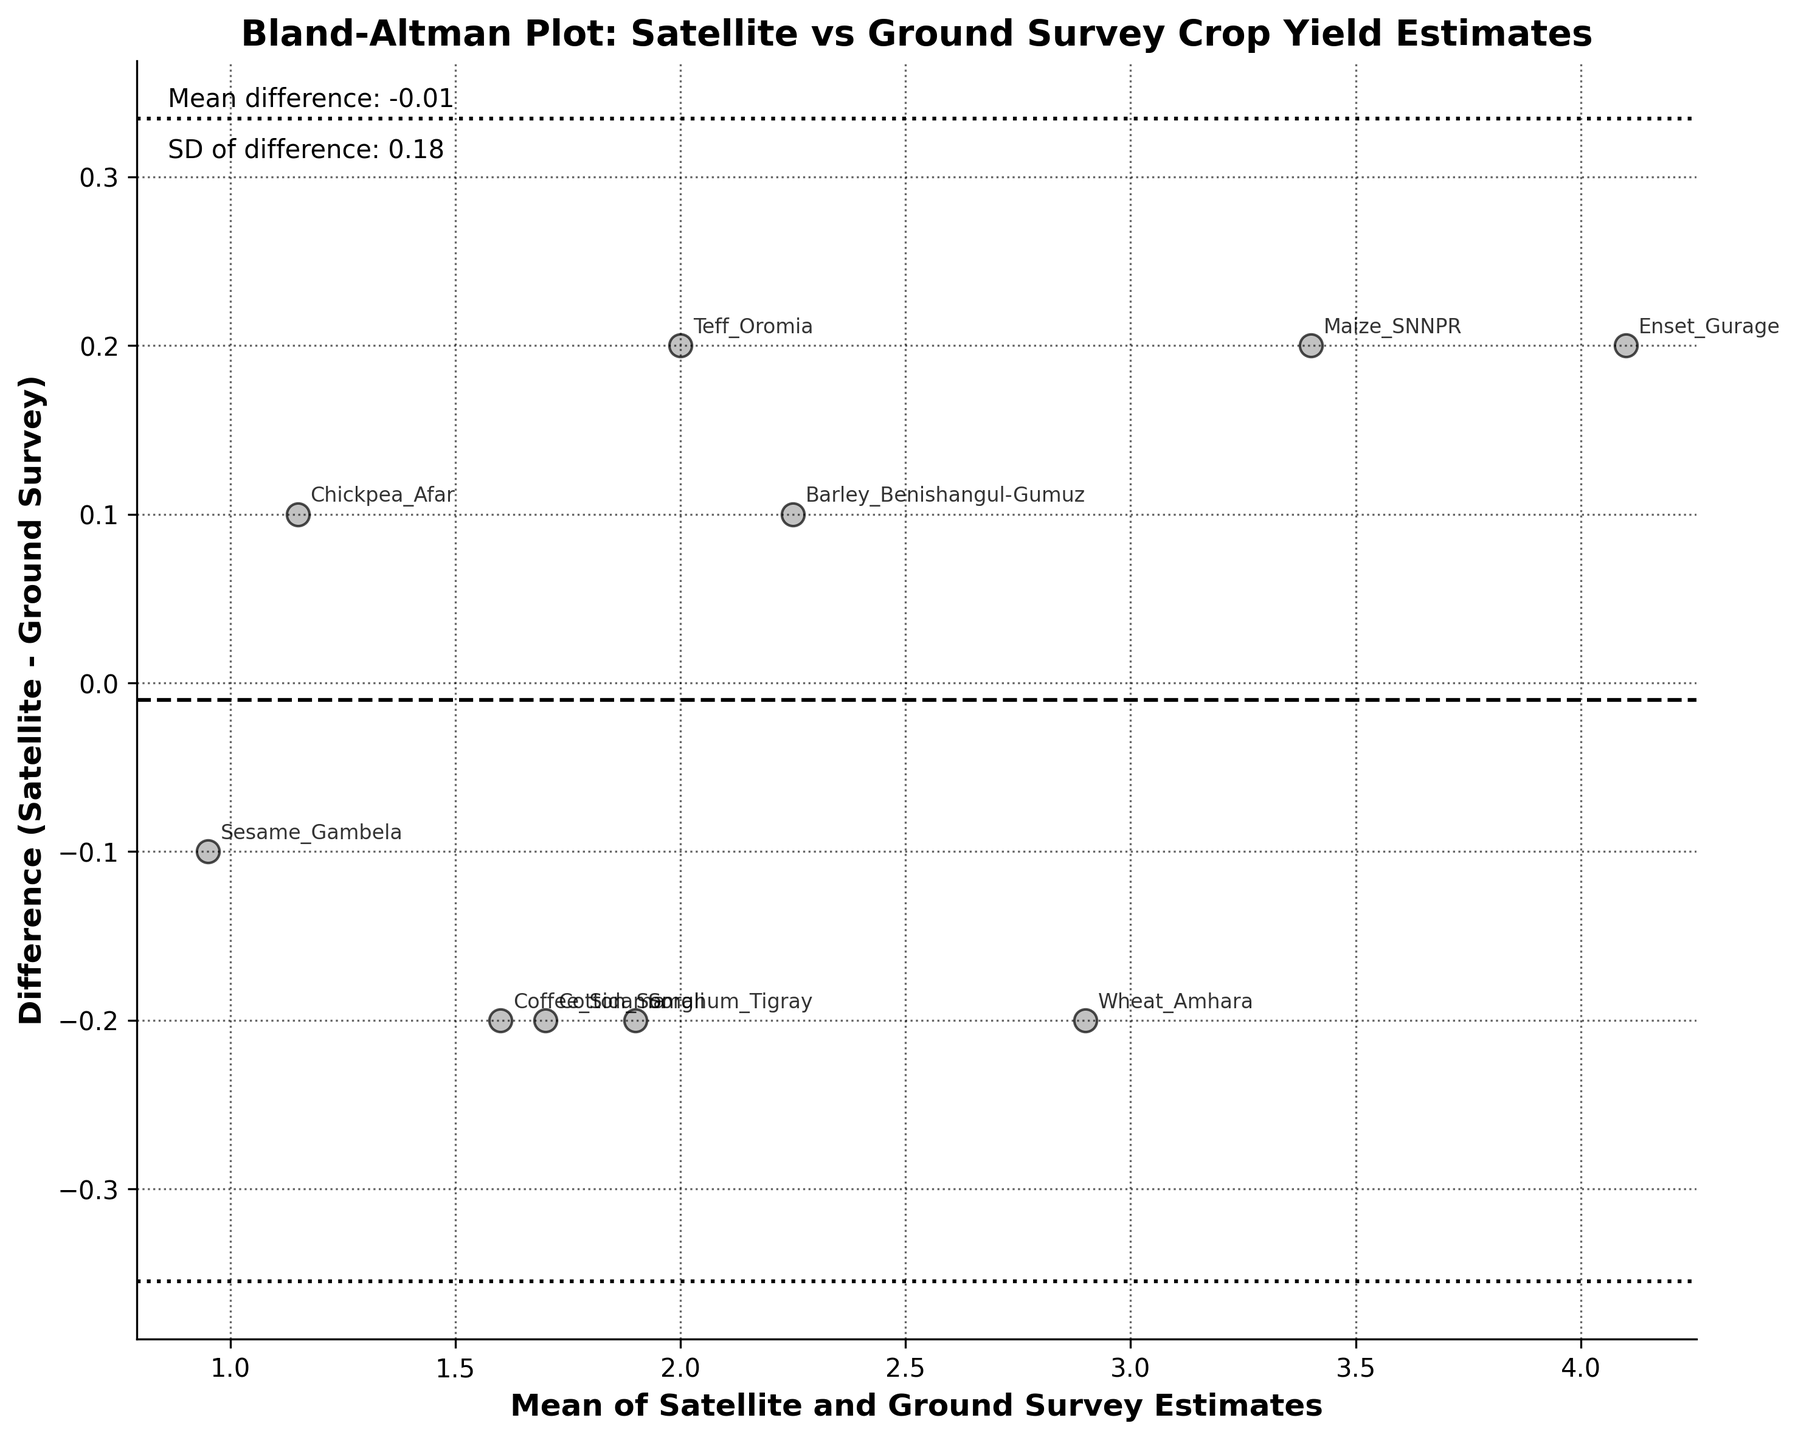What is the title of the plot? The title of the plot is usually displayed at the top of the figure. In this case, it's centered and bold, indicating it is the overall summary of the data being visualized.
Answer: Bland-Altman Plot: Satellite vs Ground Survey Crop Yield Estimates How many data points are there in the plot? Data points can be counted on the scatter plot where individual differences between estimates are displayed. Each crop variant's mean value and difference are plotted.
Answer: 10 Which crop has the smallest difference between satellite and ground survey estimates? Look for the data point closest to the horizontal zero line, which indicates the smallest difference between estimates. Identify the annotated crop name closest to this line.
Answer: Chickpea_Afar What is the mean difference between the satellite and ground survey estimates? This value is likely annotated directly in the plot. It represents the average difference between the satellite and ground-based measurements.
Answer: 0.00 What is the standard deviation of the difference between the satellite and ground estimates? This value should also be annotated in the plot, usually along with the mean difference. It indicates the spread of the differences around the mean difference.
Answer: 0.28 Which crop has the most significant positive difference between satellite and ground survey estimates? Identify the point farthest above the zero line on the vertical axis (positive side). The annotated crop name at this point shows the largest positive difference.
Answer: Enset_Gurage Are there any crops with a negative difference between the two estimates? If so, name one. Look for points below the zero line on the vertical axis. These indicate negative differences. Identify the annotated crop name closest to one of these points.
Answer: Teff_Oromia What are the upper and lower limits of agreement in this plot? Limits of agreement are marked by dashed lines usually at ±1.96 times the standard deviation from the mean difference. These are often annotated in the plot description or can be calculated from the mean and standard deviation provided.
Answer: Upper: 0.54, Lower: -0.54 Which crop has a mean estimate around 2.0? Locate the point on the horizontal axis (mean estimate) closest to the value 2.0. Identify the annotated crop name at this position.
Answer: Sorghum_Tigray What's the average mean value of the satellite and ground estimates for all the crops? To find this, sum up all the mean values (2.0 + 2.9 + etc.) and divide by the total number of crops (10). This is the average position on the horizontal axis.
Answer: 2.19 